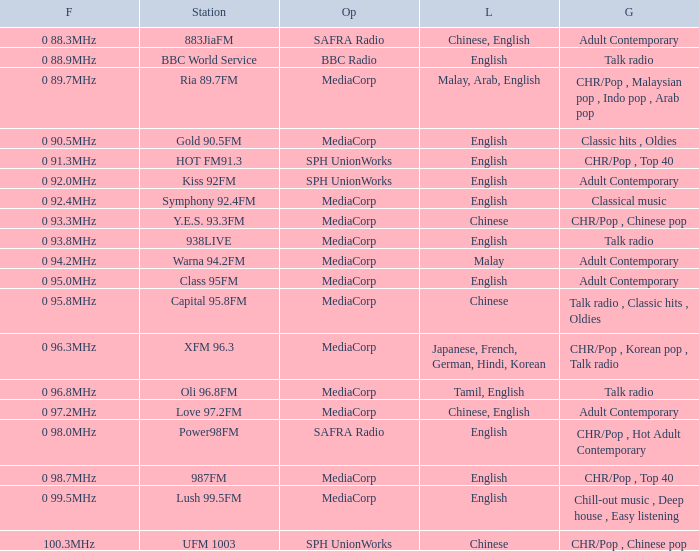Which station is managed by bbc radio in the talk radio genre? BBC World Service. 